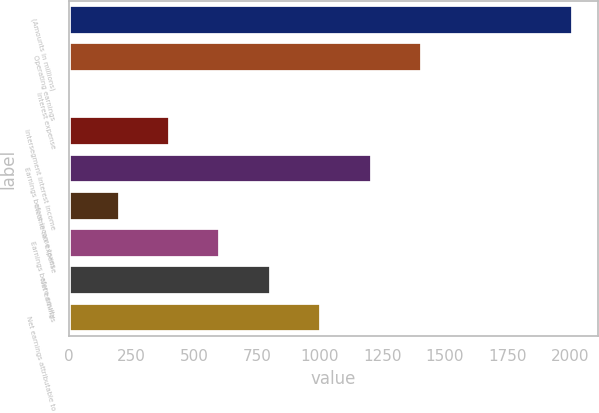Convert chart. <chart><loc_0><loc_0><loc_500><loc_500><bar_chart><fcel>(Amounts in millions)<fcel>Operating earnings<fcel>Interest expense<fcel>Intersegment interest income<fcel>Earnings before income taxes<fcel>Income tax expense<fcel>Earnings before equity<fcel>Net earnings<fcel>Net earnings attributable to<nl><fcel>2013<fcel>1409.55<fcel>1.5<fcel>403.8<fcel>1208.4<fcel>202.65<fcel>604.95<fcel>806.1<fcel>1007.25<nl></chart> 